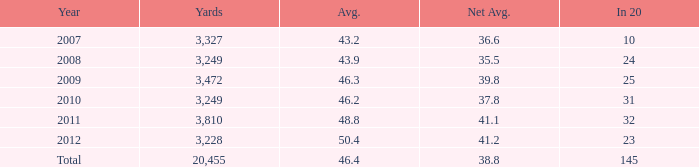What number of Yards has 32 as an In 20? 1.0. 